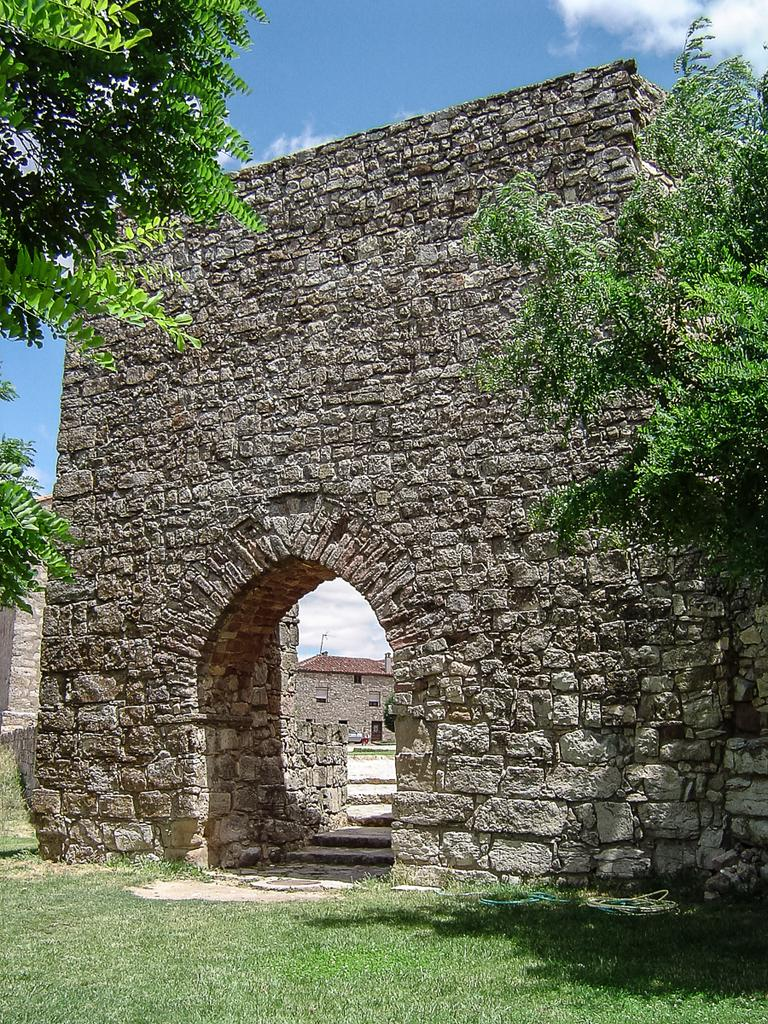What type of natural elements can be seen in the image? There are trees in the image. What type of man-made structure is present in the image? There is a building in the image. What architectural feature is visible in the image? There is an arch in the image. How would you describe the color of the sky in the image? The sky is a combination of white and blue colors. Where is the calculator located in the image? There is no calculator present in the image. What type of flower can be seen growing near the building in the image? There is no flower present in the image. 